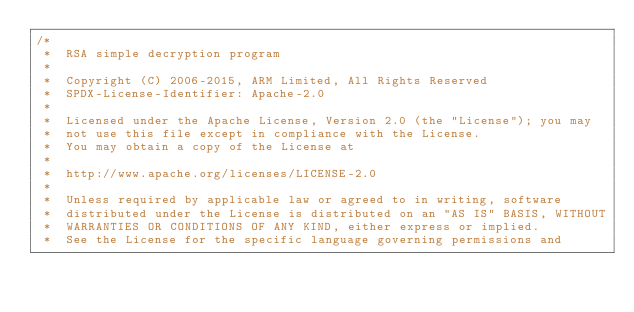Convert code to text. <code><loc_0><loc_0><loc_500><loc_500><_C_>/*
 *  RSA simple decryption program
 *
 *  Copyright (C) 2006-2015, ARM Limited, All Rights Reserved
 *  SPDX-License-Identifier: Apache-2.0
 *
 *  Licensed under the Apache License, Version 2.0 (the "License"); you may
 *  not use this file except in compliance with the License.
 *  You may obtain a copy of the License at
 *
 *  http://www.apache.org/licenses/LICENSE-2.0
 *
 *  Unless required by applicable law or agreed to in writing, software
 *  distributed under the License is distributed on an "AS IS" BASIS, WITHOUT
 *  WARRANTIES OR CONDITIONS OF ANY KIND, either express or implied.
 *  See the License for the specific language governing permissions and</code> 